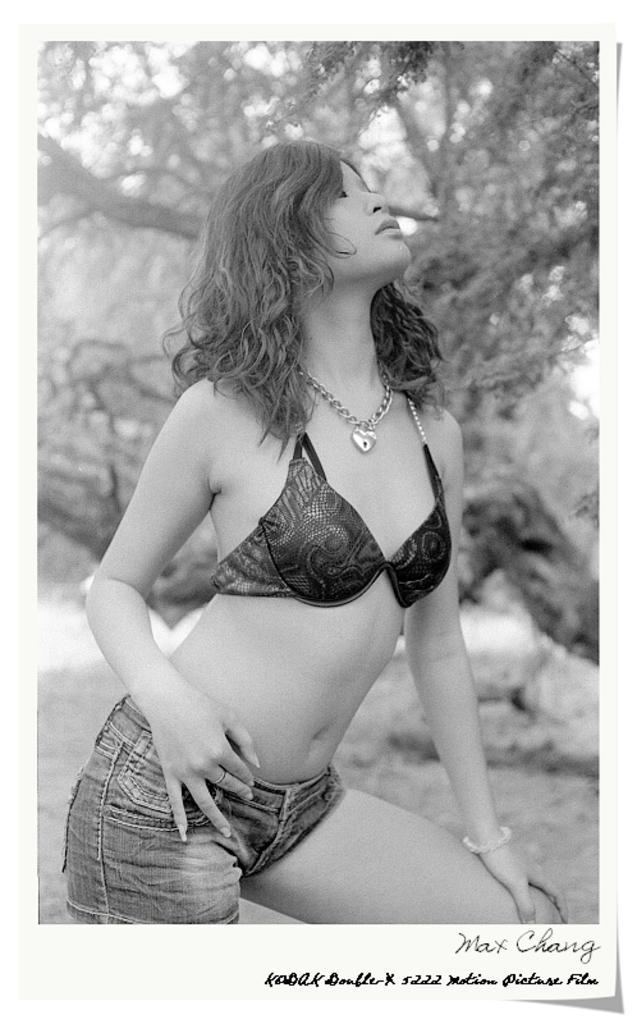In one or two sentences, can you explain what this image depicts? In this picture there is a girl in the center of the image and there are trees in the background area of the image. 